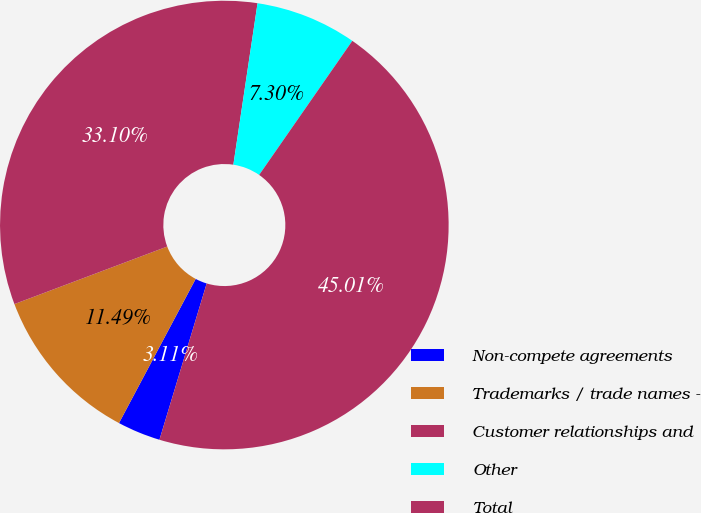Convert chart to OTSL. <chart><loc_0><loc_0><loc_500><loc_500><pie_chart><fcel>Non-compete agreements<fcel>Trademarks / trade names -<fcel>Customer relationships and<fcel>Other<fcel>Total<nl><fcel>3.11%<fcel>11.49%<fcel>33.1%<fcel>7.3%<fcel>45.01%<nl></chart> 